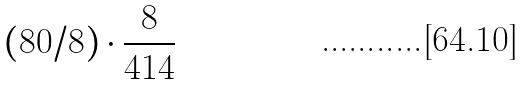Convert formula to latex. <formula><loc_0><loc_0><loc_500><loc_500>( 8 0 / 8 ) \cdot \frac { 8 } { 4 1 4 }</formula> 